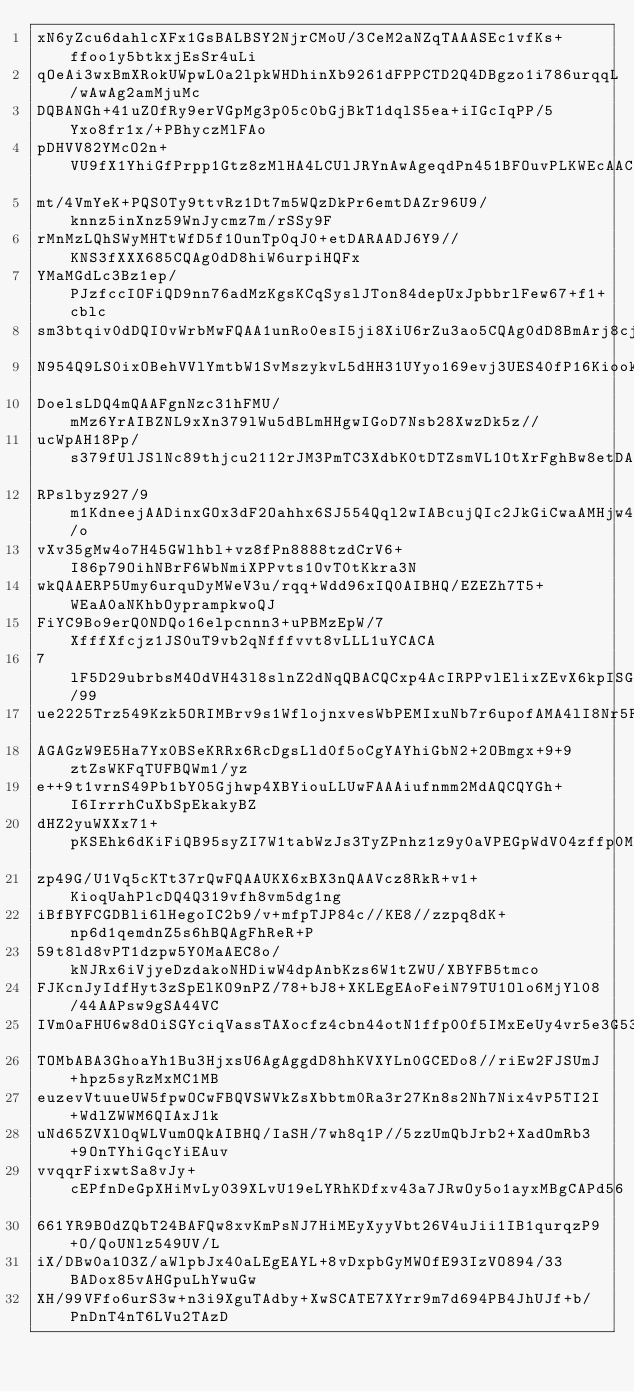Convert code to text. <code><loc_0><loc_0><loc_500><loc_500><_SQL_>xN6yZcu6dahlcXFx1GsBALBSY2NjrCMoU/3CeM2aNZqTAAASEc1vfKs+ffoo1y5btkxjEsSr4uLi
qOeAi3wxBmXRokUWpwL0a2lpkWHDhinXb9261dFPPCTD2Q4DBgzo1i786urqqL/wAwAg2amMjuMc
DQBANGh+41uZOfRy9erVGpMg3p05c0bGjBkT1dqlS5ea+iIGcIqPP/5Yxo8fr1x/+PBhyczMlFAo
pDHVV82YMcO2n+VU9fX1YhiGfPrpp1Gtz8zMlHA4LCUlJRYnAwAgeqdPn451BFOuvPLKWEcAACQo
mt/4VmYeK+PQS0Ty9ttvRz1Dt7m5WQzDkPr6emtDAZr96U9/knnz5inXnz59WnJycmz7m/rSSy9F
rMnMzLQhSWyMHTtWfD5f1OunTp0qJ0+etDARAADJ6Y9//KNS3fXXX685CQAg0dD8hiW6urpiHQFx
YMaMGdLc3Bz1ep/PJzfccIOFiQD9nn76adMzKgsKCqSyslJTon84depUxJpbbrlFew67+f1+cblc
sm3btqiv0dDQIOvWrbMwFQAA1unRo0esI5ji8XiU6rZu3ao5CQAg0dD8BmArj8cj4XBYBg0aFNX6
N954Q9LS0ixOBehVVlYmtbW1SvMszykvL5dHH31UYyo169evj3UES40fP16KiookHA5HtX7gwIES
DoelsLDQ4mQAAFgnNzc31hFMU/mMz6YrAIBZNL9xXn379lWu5dBLmHHgwIGoD7Nsb28XwzDk5z//
ucWpAH18Pp/s379fUlJSlNc89thjcu2112rJM3PmTC3XdbK0tDTZsmVL1OtXrFghBw8etDARAAB6
RPslbyz927/9m1KdneejAADinxGOx3dF2Oahhx6SJ554Qql2wIABcujQIc2JkGiCwaAMHjw46g/o
vXv35gMw4o7H45GWlhbl+vz8fPn8888tzdCrV6+I86p79OihNBrF6WbNmiXPPvts1OvT0tKkra3N
wkQAAERP5Umy6urquDyMWeV3u/rqq+Wdd96xIQ0AIBHQ/EZEZh7T5+WEaA0aNKhbOyprampkwoQJ
FiYC9Bo9erQ0NDQo16elpcnnn3+uPBMzEpW/7XfffXfcjz1JS0uT9vb2qNfffvvt8vLLL1uYCACA
7lF5D29ubrbsM4OdVH43l8slnZ2dNqQBACQCxp4AcIRPPvlElixZEvX6kpISGTx4sIWJAL3ef/99
ue2225Trz549Kzk5ORIMBrv9s1WflojnxvesWbPEMIxuNb7r6upofAMA4lI8Nr5FRNLT0yPWMPcb
AGAGzW9E5Ha7Yx0BSeKRRx6RcDgsLld0f5oCgYAYhiGbN2+2OBmgx+9+9ztZsWKFqTUFBQWm1/yz
e++9t1vrnS49Pb1bY05Gjhwp4XBYiouLLUwFAAAiufnmm2MdAQCQYGh+I6IrrrhCuXbSpEkakyBZ
dHZ2yuWXXx71+pKSEhk6dKiFiQB95syZI7W1tabWzJs3TyZPnhz1z9y0aVPEGpWdV04zffp0MQxD
zp49G/U1Vq5cKTt37rQwFQAAUKX6xBX3nQAAVcz8RkR+v1+KioqUahPlcDQ4Q319vfh8vm5dg1ng
iBfBYFCGDBli6lHegoIC2b9/v+mfpTJP84c//KE8//zzpq8dK+np6d1qemdnZ5s6hBQAgFhReR+P
59t8ld8vPT1dzpw5Y0MaAEC8o/kNJRx6iVjyeDzdakoNHDiwW4dpAnbKzs6W1tZWU/XBYFB5tmco
FJKcnJyIdfHyt3zSpElKO9nPZ/78+bJ8+XKLEgEAoFeiN79TU1Olo6MjYl08/44AAPsw9gSA44VC
IVm0aFHU6w8dOiSGYciqVassTAXocfz4cbn44otN1ffp00f5IMxEeUy4vr5e3G53txrfPXr0kHA4
TOMbABA3GhoaYh1Bu3HjxsU6AgAggdD8hhKVXYLn0GCEDo8//riEw2FJSUmJ+hpz5syRzMxMC1MB
euzevVtuueUW5fpwOCwFBQVSWVkZsXbbtm0Ra3r27Kn8s2Nh7Nix4vP5TI2I+WdlZWWM6QIAxJ1k
uNd65ZVXlOqWLVumOQkAIBHQ/IaSH/7wh8q1P//5zzUmQbJrb2+XadOmRb3+9OnTYhiGqcYiEAuv
vvqqrFixwtSa8vJy+cEPfnDeGpXHiMvLy039XLvU19eLYRhKDfxv43a7JRwOy5o1ayxMBgCAPd56
661YR9BOdZQbT24BAFQw8xvKmPsNJ7HiMEyXyyVbt26V4uJii1IB1qurqzP9+O/QoUNlz549UV/L
iX/DBw0a1O3Z/aWlpbJx40aLEgEAYL+8vDxpbGyMWOfE93IzVO894/33BADox85vAHGpuLhYwuGw
XH/99VFfo6urS3w+n3i9XguTAdby+XwSCATE7XYrr9m7d694PB4JhUJf+b/PnDnT4nT6LVu2TAzD</code> 